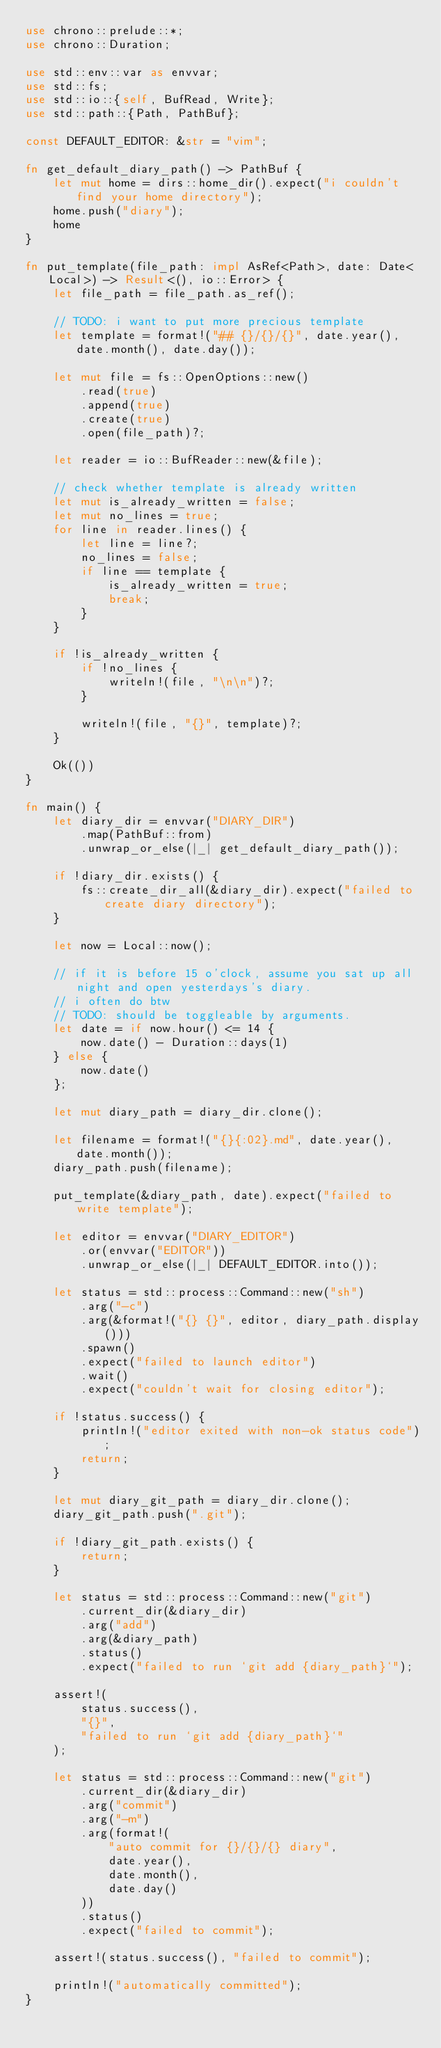Convert code to text. <code><loc_0><loc_0><loc_500><loc_500><_Rust_>use chrono::prelude::*;
use chrono::Duration;

use std::env::var as envvar;
use std::fs;
use std::io::{self, BufRead, Write};
use std::path::{Path, PathBuf};

const DEFAULT_EDITOR: &str = "vim";

fn get_default_diary_path() -> PathBuf {
    let mut home = dirs::home_dir().expect("i couldn't find your home directory");
    home.push("diary");
    home
}

fn put_template(file_path: impl AsRef<Path>, date: Date<Local>) -> Result<(), io::Error> {
    let file_path = file_path.as_ref();

    // TODO: i want to put more precious template
    let template = format!("## {}/{}/{}", date.year(), date.month(), date.day());

    let mut file = fs::OpenOptions::new()
        .read(true)
        .append(true)
        .create(true)
        .open(file_path)?;

    let reader = io::BufReader::new(&file);

    // check whether template is already written
    let mut is_already_written = false;
    let mut no_lines = true;
    for line in reader.lines() {
        let line = line?;
        no_lines = false;
        if line == template {
            is_already_written = true;
            break;
        }
    }

    if !is_already_written {
        if !no_lines {
            writeln!(file, "\n\n")?;
        }

        writeln!(file, "{}", template)?;
    }

    Ok(())
}

fn main() {
    let diary_dir = envvar("DIARY_DIR")
        .map(PathBuf::from)
        .unwrap_or_else(|_| get_default_diary_path());

    if !diary_dir.exists() {
        fs::create_dir_all(&diary_dir).expect("failed to create diary directory");
    }

    let now = Local::now();

    // if it is before 15 o'clock, assume you sat up all night and open yesterdays's diary.
    // i often do btw
    // TODO: should be toggleable by arguments.
    let date = if now.hour() <= 14 {
        now.date() - Duration::days(1)
    } else {
        now.date()
    };

    let mut diary_path = diary_dir.clone();

    let filename = format!("{}{:02}.md", date.year(), date.month());
    diary_path.push(filename);

    put_template(&diary_path, date).expect("failed to write template");

    let editor = envvar("DIARY_EDITOR")
        .or(envvar("EDITOR"))
        .unwrap_or_else(|_| DEFAULT_EDITOR.into());

    let status = std::process::Command::new("sh")
        .arg("-c")
        .arg(&format!("{} {}", editor, diary_path.display()))
        .spawn()
        .expect("failed to launch editor")
        .wait()
        .expect("couldn't wait for closing editor");

    if !status.success() {
        println!("editor exited with non-ok status code");
        return;
    }

    let mut diary_git_path = diary_dir.clone();
    diary_git_path.push(".git");

    if !diary_git_path.exists() {
        return;
    }

    let status = std::process::Command::new("git")
        .current_dir(&diary_dir)
        .arg("add")
        .arg(&diary_path)
        .status()
        .expect("failed to run `git add {diary_path}`");

    assert!(
        status.success(),
        "{}",
        "failed to run `git add {diary_path}`"
    );

    let status = std::process::Command::new("git")
        .current_dir(&diary_dir)
        .arg("commit")
        .arg("-m")
        .arg(format!(
            "auto commit for {}/{}/{} diary",
            date.year(),
            date.month(),
            date.day()
        ))
        .status()
        .expect("failed to commit");

    assert!(status.success(), "failed to commit");

    println!("automatically committed");
}
</code> 